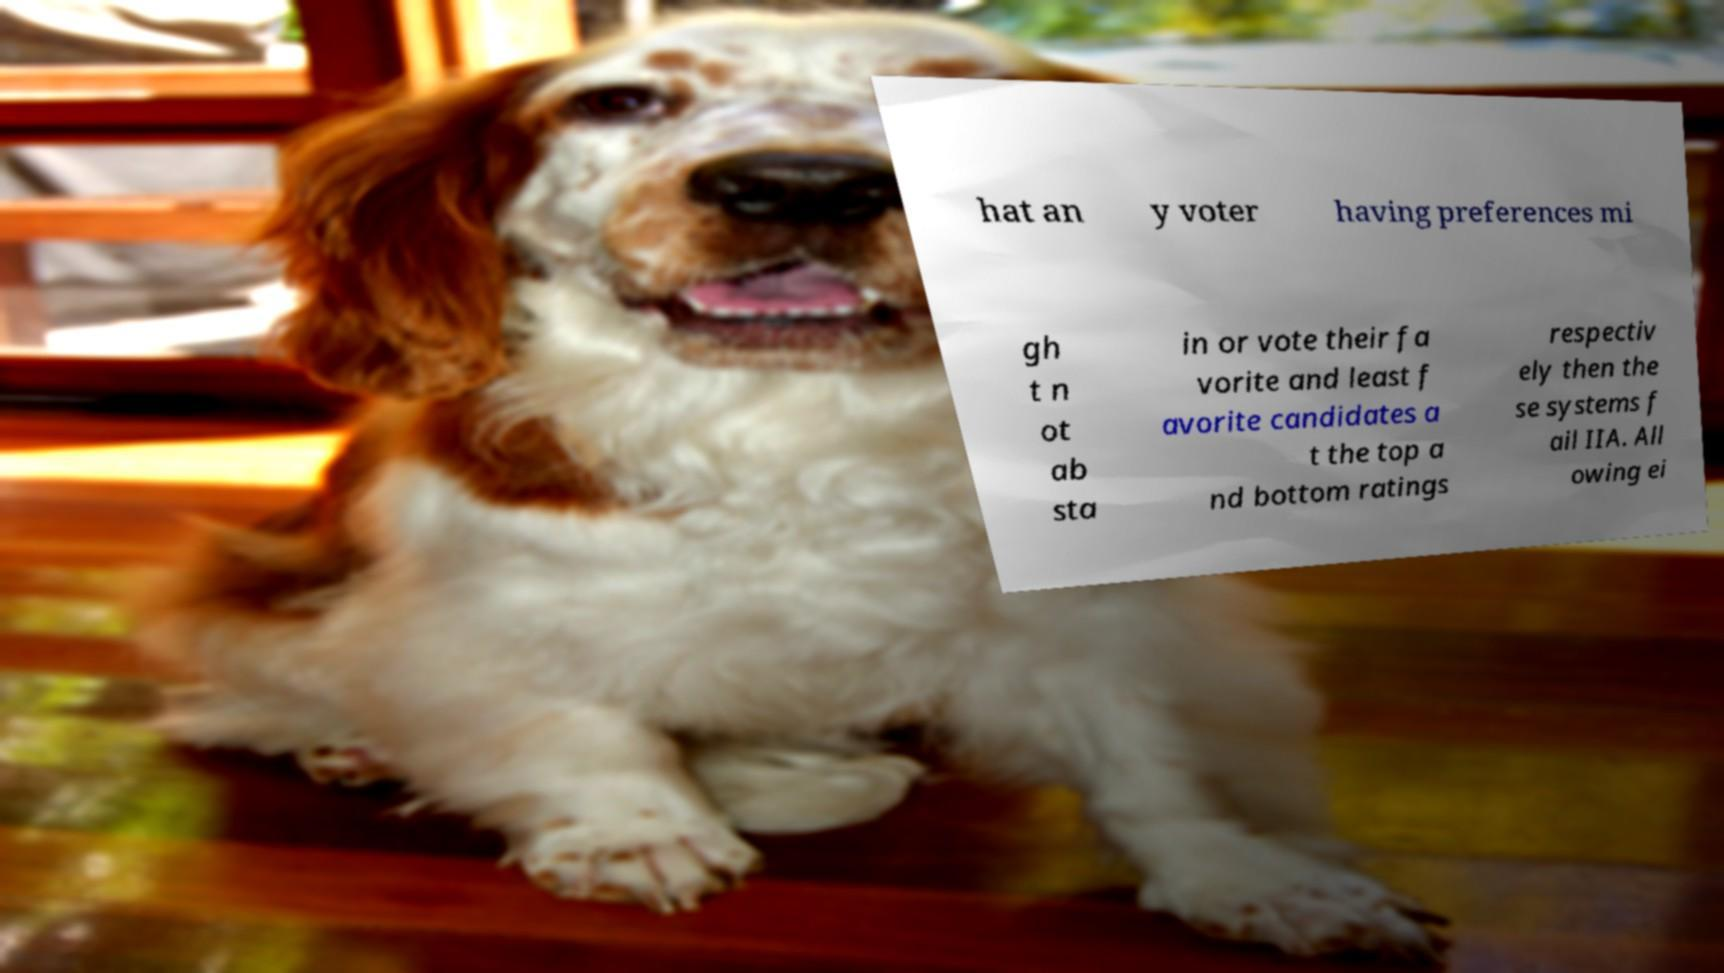Can you accurately transcribe the text from the provided image for me? hat an y voter having preferences mi gh t n ot ab sta in or vote their fa vorite and least f avorite candidates a t the top a nd bottom ratings respectiv ely then the se systems f ail IIA. All owing ei 